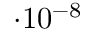<formula> <loc_0><loc_0><loc_500><loc_500>\cdot 1 0 ^ { - 8 }</formula> 